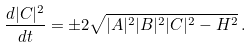Convert formula to latex. <formula><loc_0><loc_0><loc_500><loc_500>\frac { d | C | ^ { 2 } } { d t } = \pm 2 \sqrt { | A | ^ { 2 } | B | ^ { 2 } | C | ^ { 2 } - H ^ { 2 } } \, .</formula> 